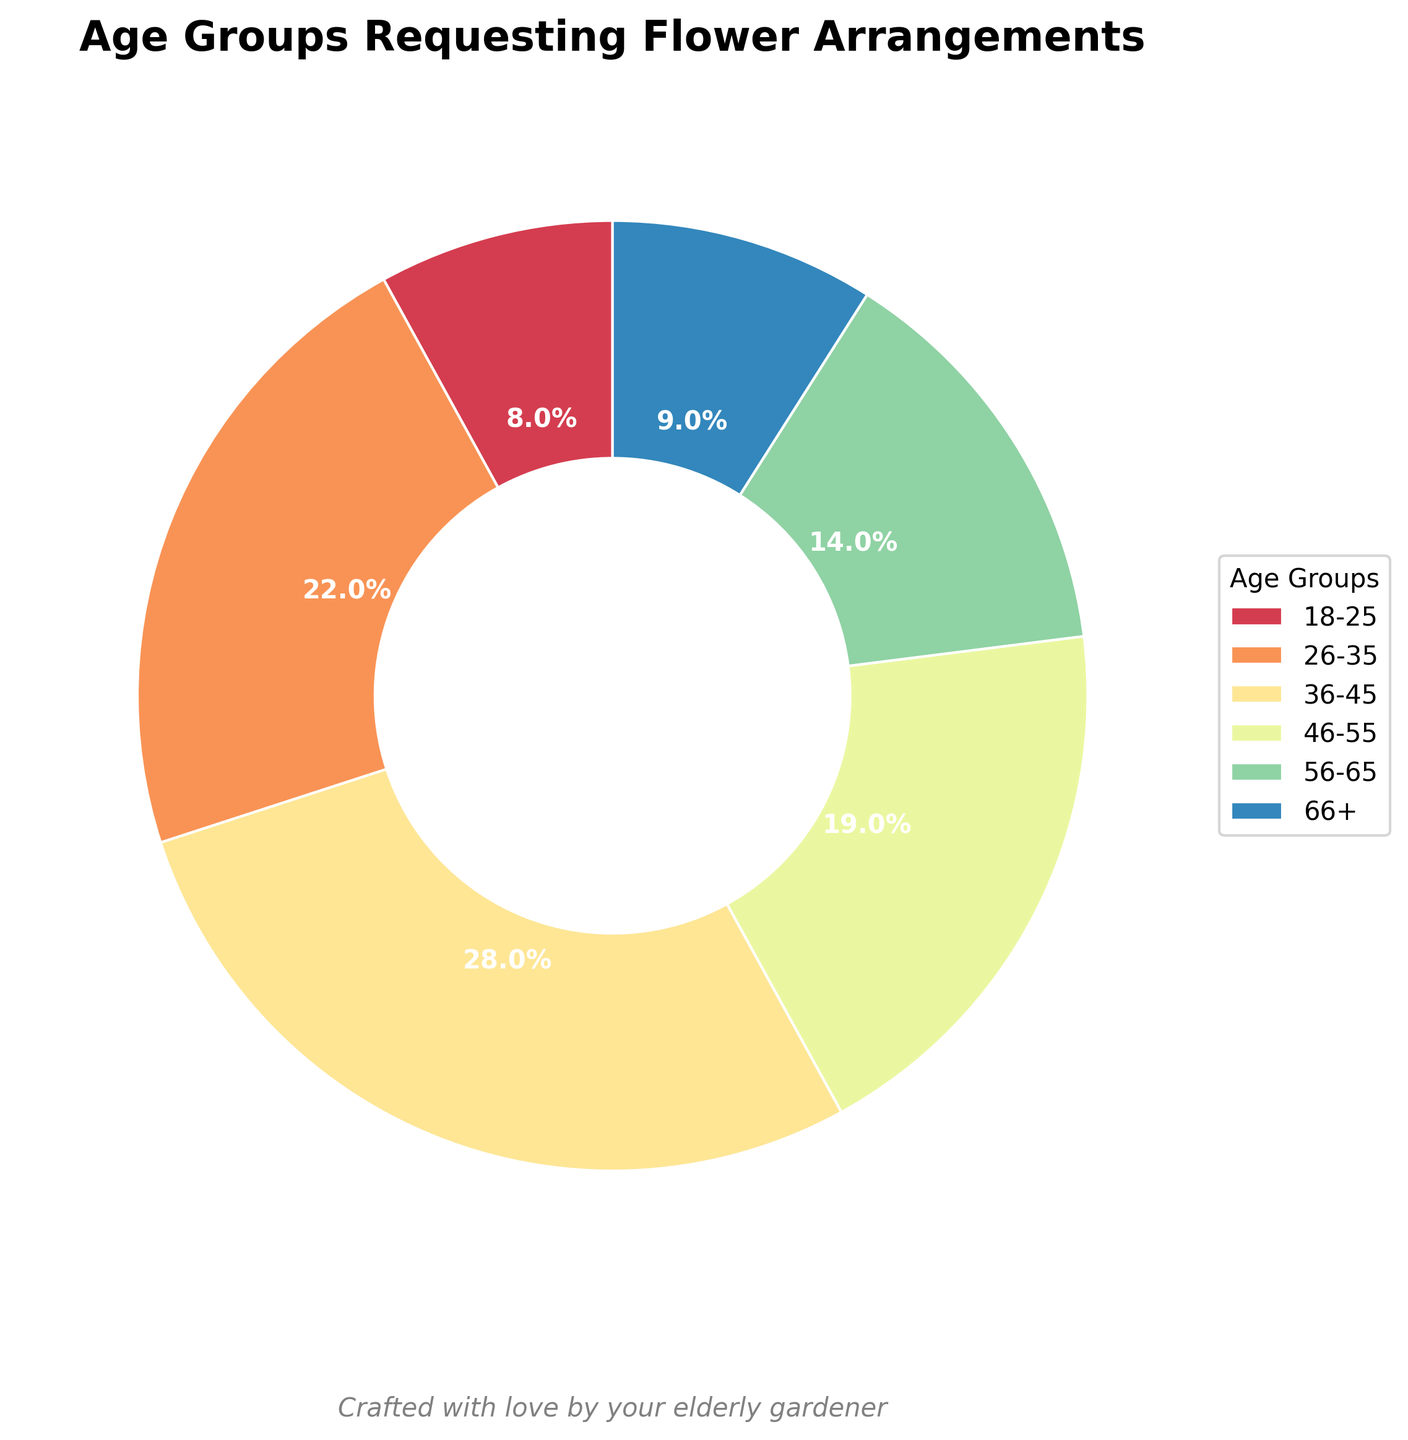What is the percentage of clients aged 36-45? The pie chart segment labeled "36-45" shows the percentage.
Answer: 28% Which age group has the smallest percentage of clients? By visually comparing the sizes of the pie chart segments, the "18-25" segment is the smallest.
Answer: 18-25 What is the combined percentage of clients aged 26-35 and 46-55? The "26-35" segment is 22%, and the "46-55" segment is 19%. Adding them gives 22 + 19 = 41%.
Answer: 41% Are there more clients aged 56-65 or aged 66+? By comparing the "56-65" segment (14%) and the "66+" segment (9%), the "56-65" segment is larger.
Answer: 56-65 What is the largest segment in the pie chart? By visually examining the pie chart, the "36-45" segment appears to be the largest.
Answer: 36-45 What is the difference in percentage between the groups aged 26-35 and 56-65? The "26-35" segment is 22%, and the "56-65" segment is 14%. Subtracting them gives 22 - 14 = 8%.
Answer: 8% Which color represents the age group 46-55? The "46-55" segment has a dark purple color.
Answer: Dark Purple Is the percentage of clients aged 66+ greater than 8%? The "66+" segment shows 9%, which is greater than 8%.
Answer: Yes How many age groups have a percentage above 20%? "26-35" (22%) and "36-45" (28%) are above 20%.
Answer: 2 